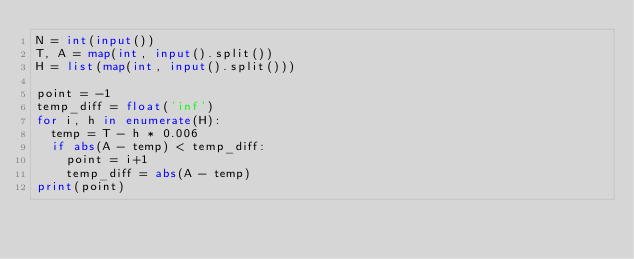<code> <loc_0><loc_0><loc_500><loc_500><_Python_>N = int(input())
T, A = map(int, input().split())
H = list(map(int, input().split()))

point = -1
temp_diff = float('inf')
for i, h in enumerate(H):
  temp = T - h * 0.006
  if abs(A - temp) < temp_diff:
    point = i+1
    temp_diff = abs(A - temp)
print(point)</code> 